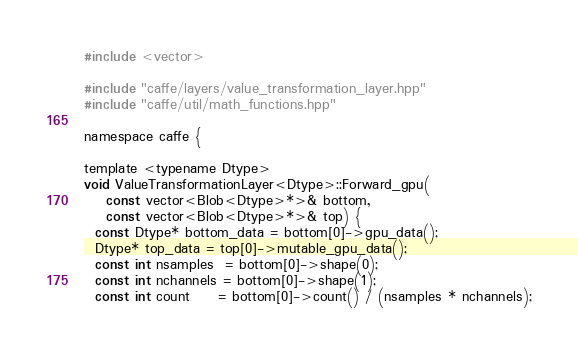Convert code to text. <code><loc_0><loc_0><loc_500><loc_500><_Cuda_>#include <vector>

#include "caffe/layers/value_transformation_layer.hpp"
#include "caffe/util/math_functions.hpp"

namespace caffe {

template <typename Dtype>
void ValueTransformationLayer<Dtype>::Forward_gpu(
    const vector<Blob<Dtype>*>& bottom,
    const vector<Blob<Dtype>*>& top) {
  const Dtype* bottom_data = bottom[0]->gpu_data();
  Dtype* top_data = top[0]->mutable_gpu_data();
  const int nsamples  = bottom[0]->shape(0);
  const int nchannels = bottom[0]->shape(1);
  const int count     = bottom[0]->count() / (nsamples * nchannels);
</code> 